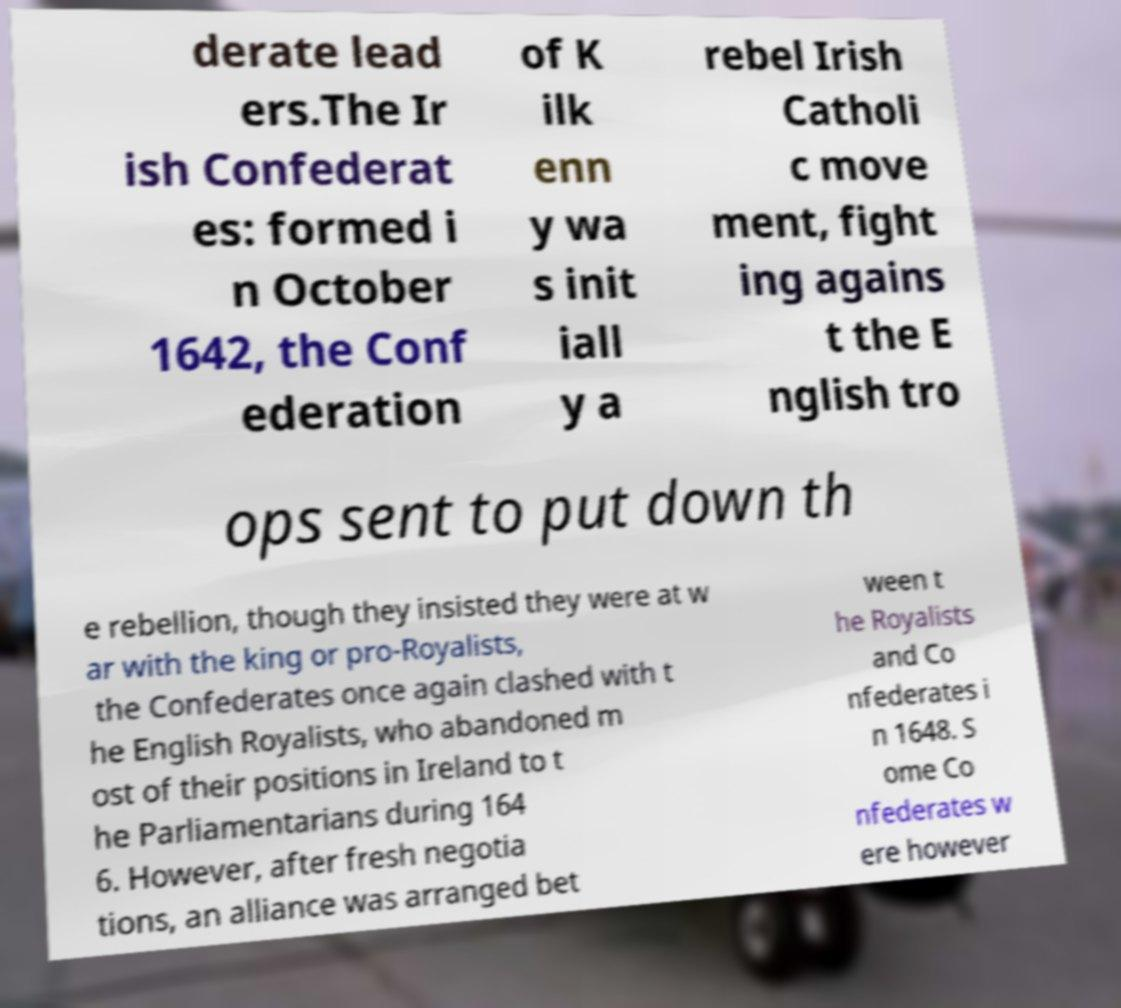There's text embedded in this image that I need extracted. Can you transcribe it verbatim? derate lead ers.The Ir ish Confederat es: formed i n October 1642, the Conf ederation of K ilk enn y wa s init iall y a rebel Irish Catholi c move ment, fight ing agains t the E nglish tro ops sent to put down th e rebellion, though they insisted they were at w ar with the king or pro-Royalists, the Confederates once again clashed with t he English Royalists, who abandoned m ost of their positions in Ireland to t he Parliamentarians during 164 6. However, after fresh negotia tions, an alliance was arranged bet ween t he Royalists and Co nfederates i n 1648. S ome Co nfederates w ere however 